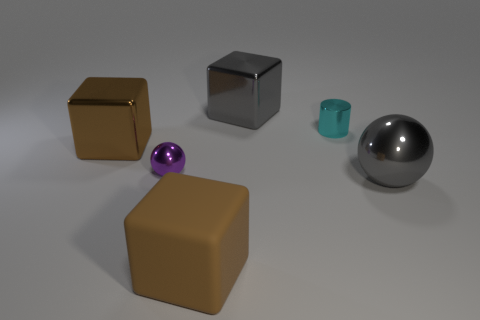Add 2 shiny cylinders. How many objects exist? 8 Subtract all balls. How many objects are left? 4 Add 5 big blocks. How many big blocks are left? 8 Add 3 small purple matte cylinders. How many small purple matte cylinders exist? 3 Subtract 0 red cubes. How many objects are left? 6 Subtract all big brown shiny objects. Subtract all gray cubes. How many objects are left? 4 